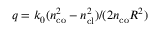<formula> <loc_0><loc_0><loc_500><loc_500>q = k _ { 0 } ( n _ { c o } ^ { 2 } - n _ { c l } ^ { 2 } ) / ( 2 n _ { c o } R ^ { 2 } )</formula> 